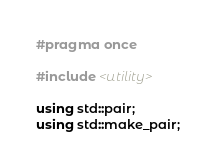<code> <loc_0><loc_0><loc_500><loc_500><_C++_>#pragma once

#include <utility>

using std::pair;
using std::make_pair;
</code> 